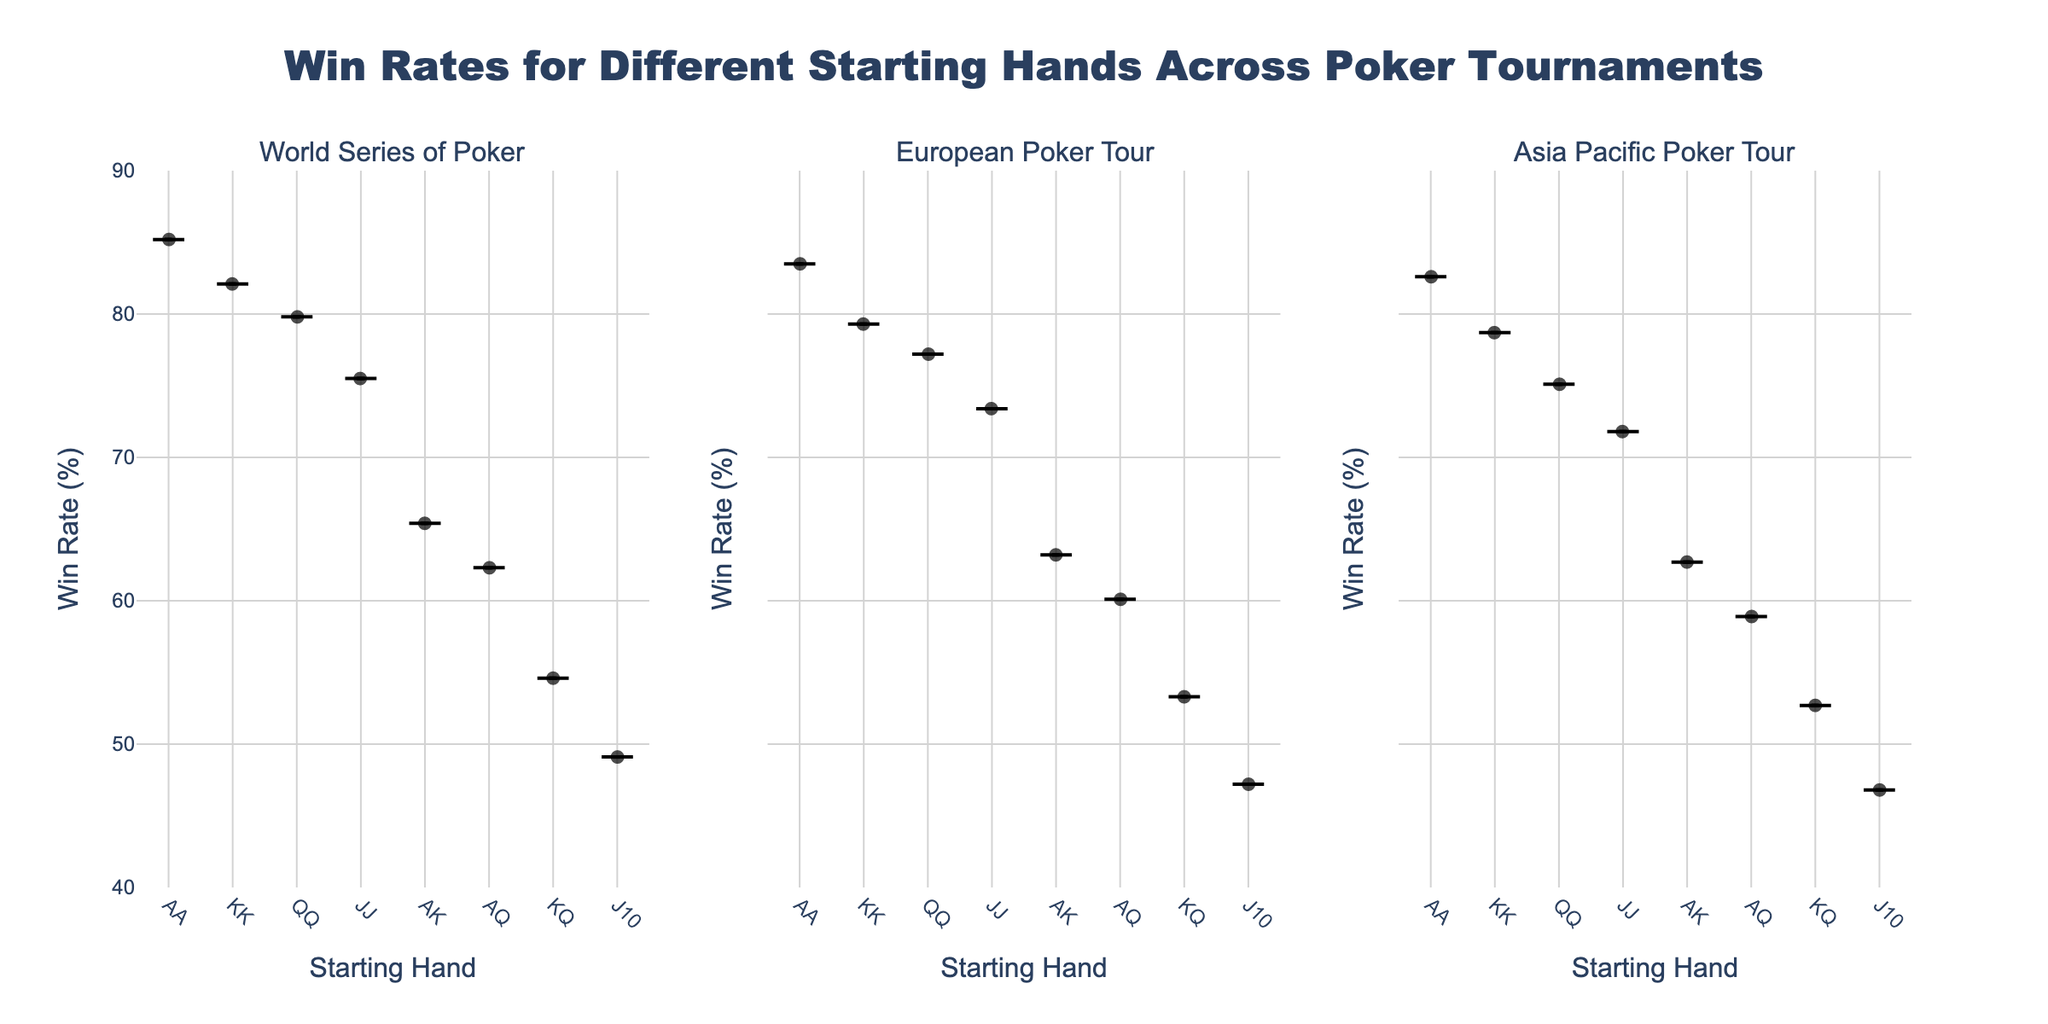How many starting hands are displayed in the figure? The figure's x-axis displays starting hands like AA, KK, QQ, etc. Counting these distinct hands gives the number of starting hands shown.
Answer: 7 Which tournament has the highest win rate for starting hand AA? By comparing the highest points on the violin plots for AA across the three subplots (World Series of Poker, European Poker Tour, Asia Pacific Poker Tour), it's clear which one touches the highest win rate.
Answer: World Series of Poker What's the title of the figure? The title is usually prominently displayed at the top of the figure. The provided code confirms the title.
Answer: Win Rates for Different Starting Hands Across Poker Tournaments Which starting hand has the lowest win rate in the Asia Pacific Poker Tour? Look at the lowest points on the violin plot from the Asia Pacific Poker Tour subplot to identify which starting hand has the lowest win rate.
Answer: J10 List the tournaments in descending order of win rate for the starting hand KK. Comparative observation of the highest points on the violin plots for KK in the respective subplots helps in ranking the tournaments based on win rates.
Answer: World Series of Poker, European Poker Tour, Asia Pacific Poker Tour What is the range of win rates displayed on the y-axis? Checking the label of the y-axis, its beginning value, and its maximum value gives the range.
Answer: 40% to 90% Calculate the difference in win rate for hand QQ between World Series of Poker and European Poker Tour. Subtract the win rate of QQ in European Poker Tour from its win rate in the World Series of Poker (79.8% - 77.2%).
Answer: 2.6% Which starting hand has the largest spread of win rates in the European Poker Tour? By measuring the vertical span of the violin plots in the European Poker Tour subplot, it's possible to see which hand has the largest spread.
Answer: AK How does the average win rate of hand AK across all tournaments compare to the average of hand AQ across all tournaments? Calculate the average win rate for AK (65.4 + 63.2 + 62.7)/3 and for AQ (62.3 + 60.1 + 58.9)/3, then compare these averages.
Answer: AK has a higher average For starting hand JJ, which tournament shows the median win rate? The median of a dataset is the middle value. Observing the central line in each violin plot for JJ tells which tournament's violin plot's bulge is closer to the median.
Answer: European Poker Tour 